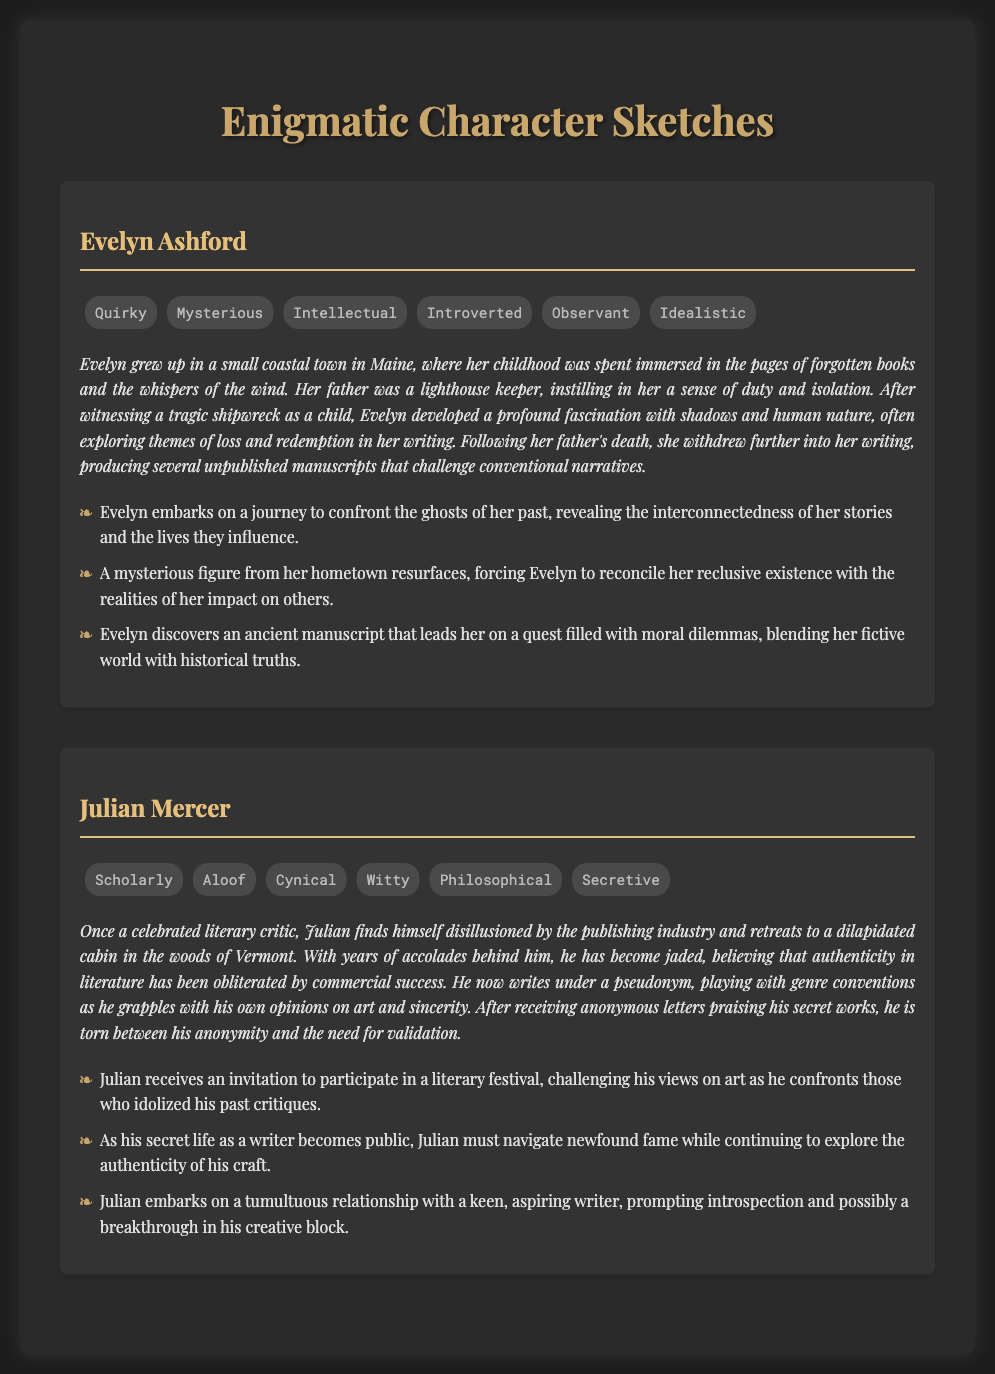What is the name of the first character? The first character is listed under the character title in the document.
Answer: Evelyn Ashford What is Julian Mercer's personality trait that indicates his detachment? The document lists various traits that describe Julian, one of which implies his distance from others.
Answer: Aloof In which state does Julian Mercer live? The document provides the location of Julian's cabin.
Answer: Vermont What profession did Julian Mercer have before retreating? This information is specifically provided in Julian's backstory.
Answer: Literary critic What significant event influenced Evelyn Ashford's fascination with shadows? The document mentions a particular incident from her childhood that sparked this interest.
Answer: Tragic shipwreck How many potential narrative arcs are suggested for Evelyn? The document includes a list of potential narrative arcs for character development.
Answer: Three What theme does Evelyn often explore in her writing? This theme is mentioned in her backstory and is a key aspect of her character.
Answer: Loss and redemption What does Julian seek to regain through his writing? The document describes Julian's internal struggle with his craft.
Answer: Authenticity What nickname does Julian use for his writing? The document refers to the name he writes under, highlighting part of his secretive nature.
Answer: Pseudonym 